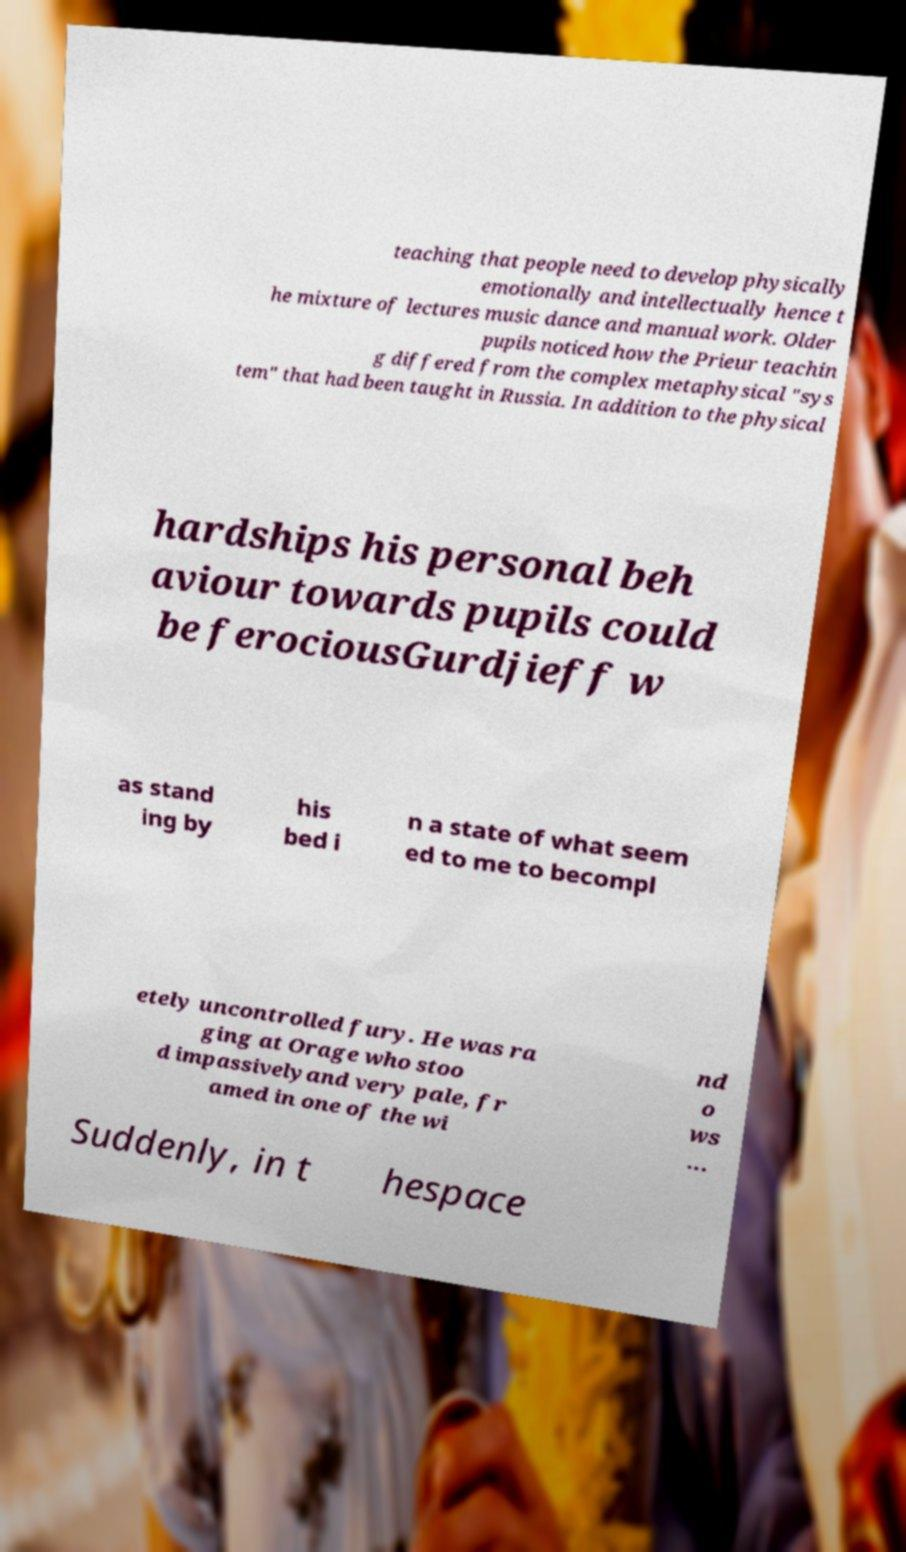What messages or text are displayed in this image? I need them in a readable, typed format. teaching that people need to develop physically emotionally and intellectually hence t he mixture of lectures music dance and manual work. Older pupils noticed how the Prieur teachin g differed from the complex metaphysical "sys tem" that had been taught in Russia. In addition to the physical hardships his personal beh aviour towards pupils could be ferociousGurdjieff w as stand ing by his bed i n a state of what seem ed to me to becompl etely uncontrolled fury. He was ra ging at Orage who stoo d impassivelyand very pale, fr amed in one of the wi nd o ws ... Suddenly, in t hespace 